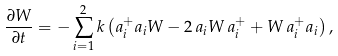Convert formula to latex. <formula><loc_0><loc_0><loc_500><loc_500>\frac { \partial W } { \partial t } = - \sum _ { i = 1 } ^ { 2 } k \left ( a _ { i } ^ { + } a _ { i } W - 2 \, a _ { i } W \, a _ { i } ^ { + } + W \, a _ { i } ^ { + } a _ { i } \right ) ,</formula> 